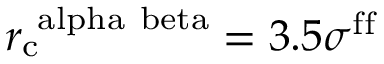<formula> <loc_0><loc_0><loc_500><loc_500>r _ { c } ^ { \ a l p h a \ b e t a } = 3 . 5 \sigma ^ { f f }</formula> 